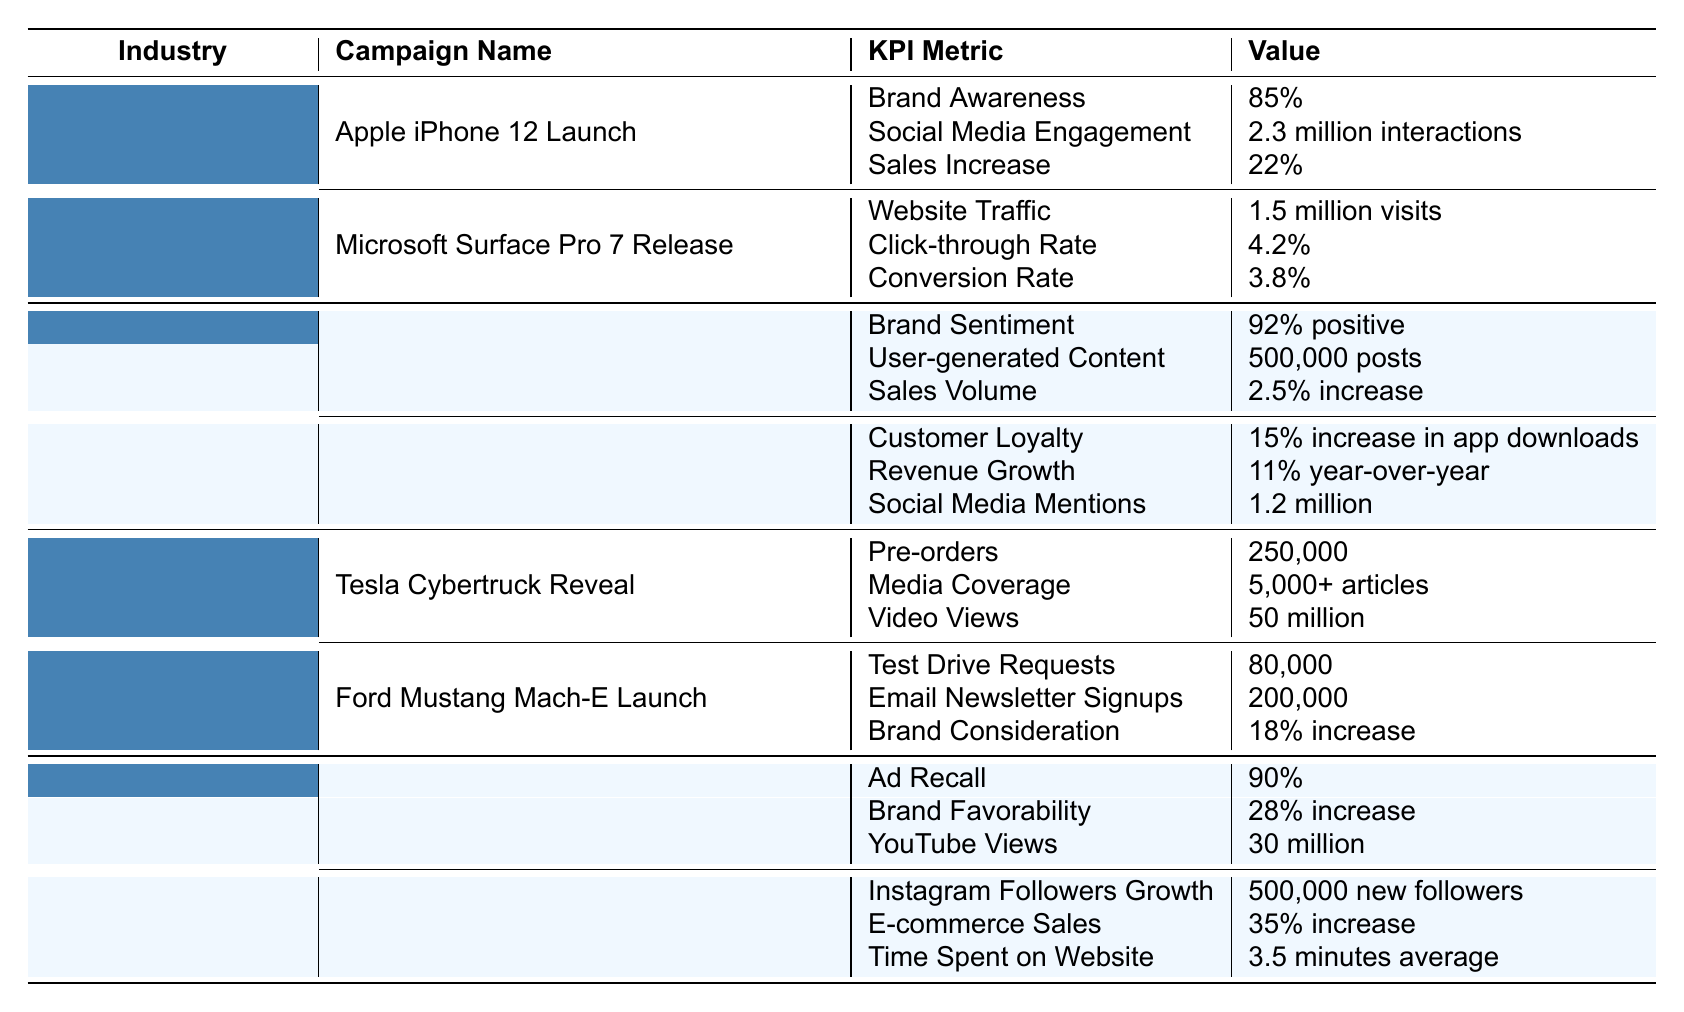What is the brand awareness percentage for the Apple iPhone 12 Launch campaign? The table shows that the brand awareness for the Apple iPhone 12 Launch campaign is 85%.
Answer: 85% How many interactions did the Apple iPhone 12 Launch campaign achieve on social media? According to the table, the Apple iPhone 12 Launch campaign had 2.3 million interactions on social media.
Answer: 2.3 million interactions Which Food and Beverage campaign had the highest brand sentiment? The Coca-Cola 'Share a Coke' campaign had a brand sentiment of 92%, which is higher than the Starbucks campaign.
Answer: Coca-Cola 'Share a Coke' What was the increase in sales volume for the Coca-Cola 'Share a Coke' campaign? The sales volume increase for the Coca-Cola campaign was reported as a 2.5% increase according to the table.
Answer: 2.5% increase What is the total number of pre-orders for the Tesla Cybertruck Reveal campaign? The table states that the Tesla Cybertruck Reveal campaign received a total of 250,000 pre-orders.
Answer: 250,000 Which Automotive campaign had more test drive requests, Tesla Cybertruck Reveal or Ford Mustang Mach-E Launch? The Ford Mustang Mach-E Launch had 80,000 test drive requests, while the Tesla Cybertruck Reveal had none listed. Therefore, the Ford campaign had more test drive requests.
Answer: Ford Mustang Mach-E Launch Calculate the total media coverage for both Automotive campaigns. The Tesla Cybertruck Reveal received media coverage of 5,000 articles, and the Ford Mustang Mach-E Launch has none listed. Therefore, the total media coverage is 5,000 articles.
Answer: 5,000 articles What was the percentage increase in brand favorability for Nike's 'Dream Crazier' campaign? The Nike 'Dream Crazier' campaign achieved a 28% increase in brand favorability, as indicated in the table.
Answer: 28% increase True or False: The Starbucks campaign had more app downloads than the Coca-Cola campaign had positive brand sentiment. The table states that the Starbucks campaign saw a 15% increase in app downloads, while the Coca-Cola campaign had a 92% positive brand sentiment. Therefore, this statement is false.
Answer: False Which campaign had the highest revenue growth, and what was the percentage? The Starbucks campaign had a revenue growth of 11% year-over-year, which is more than the other listed campaigns.
Answer: Starbucks 'Pumpkin Spice Latte' Season Calculate the average customer loyalty increase from the Food and Beverage campaigns. The Coca-Cola campaign had no customer loyalty increase listed, while the Starbucks campaign had a 15% increase. Therefore, the average increase is (0 + 15)/2 = 7.5%.
Answer: 7.5% 